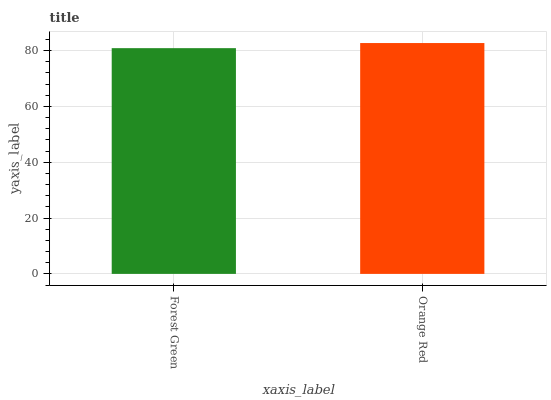Is Forest Green the minimum?
Answer yes or no. Yes. Is Orange Red the maximum?
Answer yes or no. Yes. Is Orange Red the minimum?
Answer yes or no. No. Is Orange Red greater than Forest Green?
Answer yes or no. Yes. Is Forest Green less than Orange Red?
Answer yes or no. Yes. Is Forest Green greater than Orange Red?
Answer yes or no. No. Is Orange Red less than Forest Green?
Answer yes or no. No. Is Orange Red the high median?
Answer yes or no. Yes. Is Forest Green the low median?
Answer yes or no. Yes. Is Forest Green the high median?
Answer yes or no. No. Is Orange Red the low median?
Answer yes or no. No. 